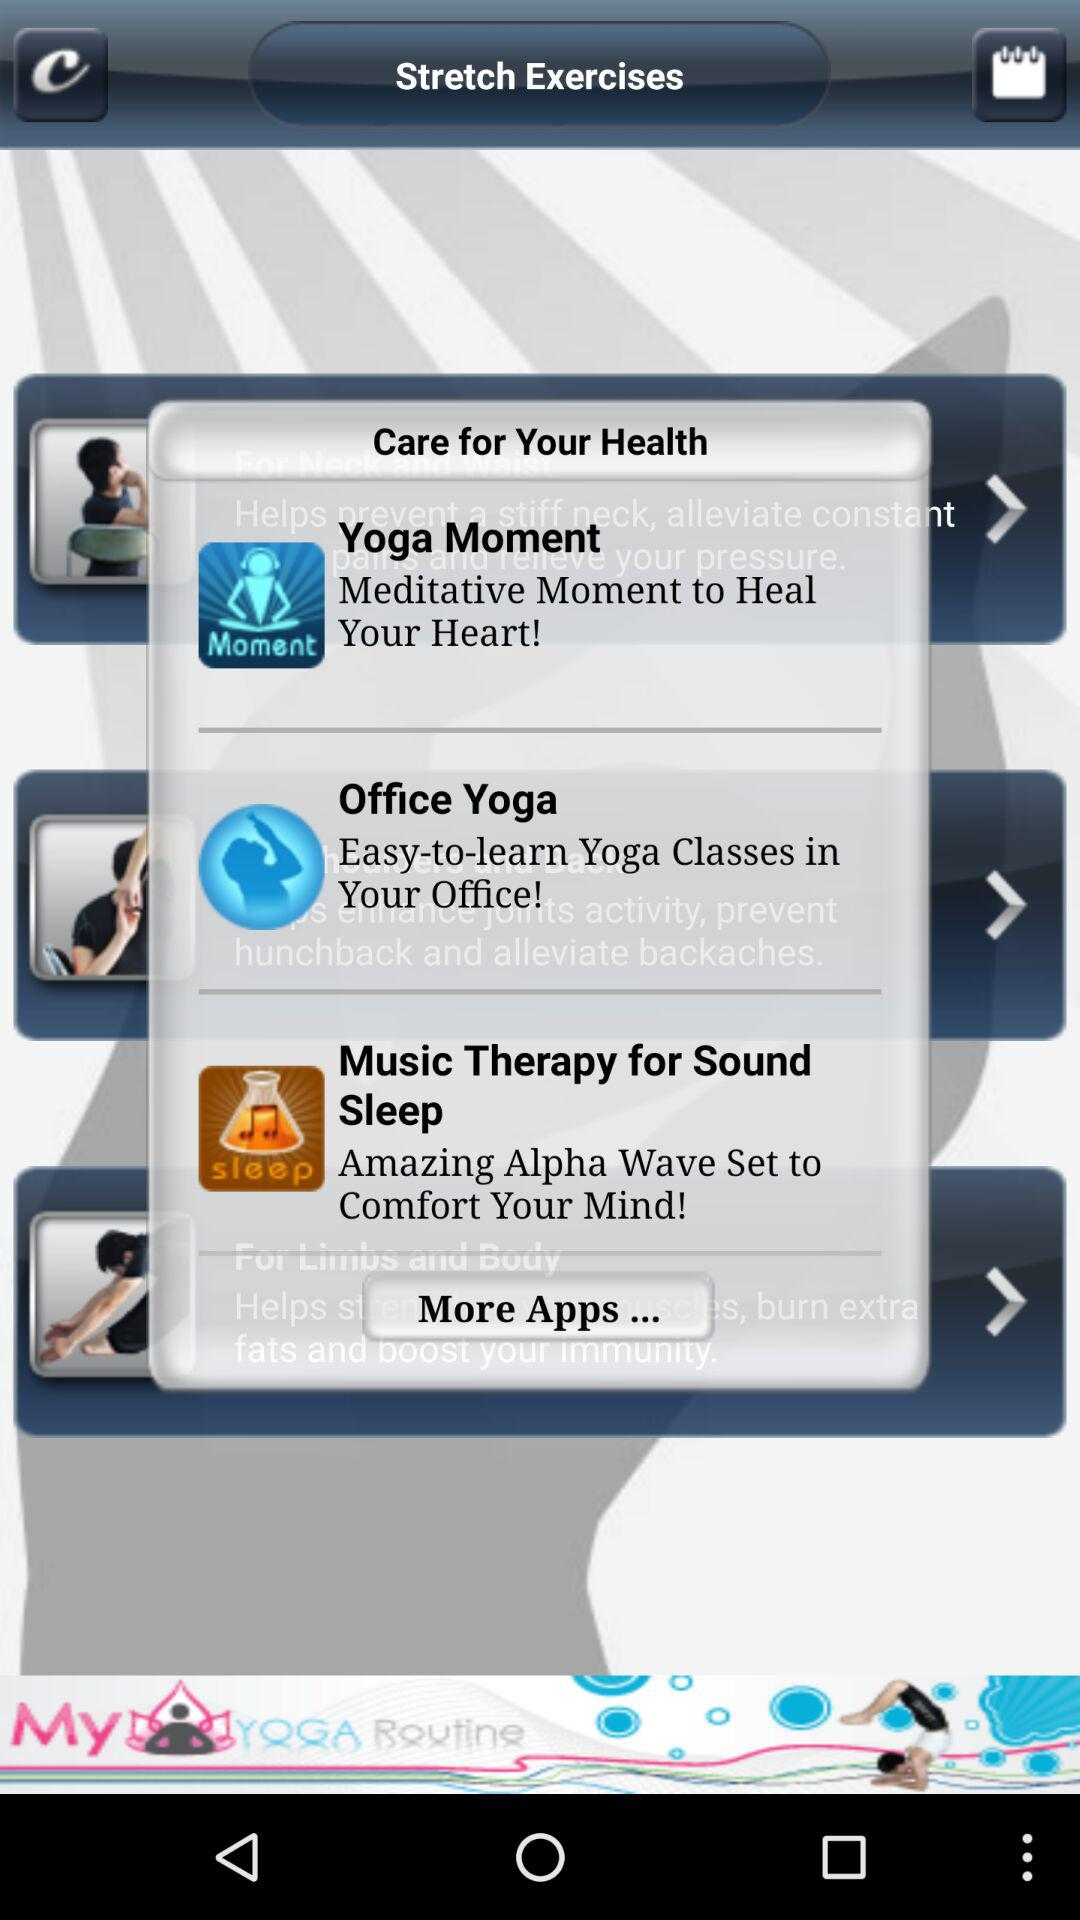What is the description of "Office Yoga"? The description of "Office Yoga" is "Easy-to-learn Yoga Classes in Your Office!". 